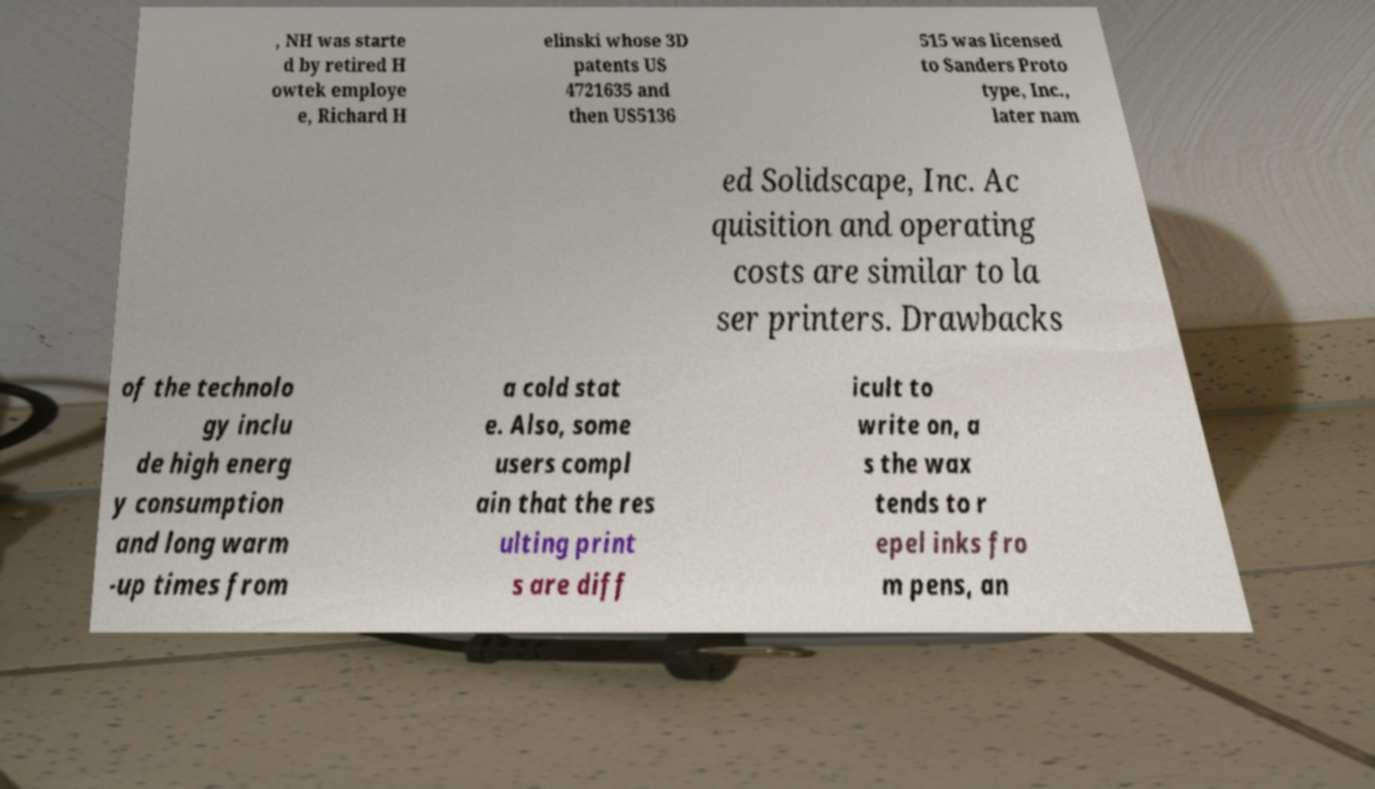Can you read and provide the text displayed in the image?This photo seems to have some interesting text. Can you extract and type it out for me? , NH was starte d by retired H owtek employe e, Richard H elinski whose 3D patents US 4721635 and then US5136 515 was licensed to Sanders Proto type, Inc., later nam ed Solidscape, Inc. Ac quisition and operating costs are similar to la ser printers. Drawbacks of the technolo gy inclu de high energ y consumption and long warm -up times from a cold stat e. Also, some users compl ain that the res ulting print s are diff icult to write on, a s the wax tends to r epel inks fro m pens, an 